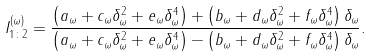Convert formula to latex. <formula><loc_0><loc_0><loc_500><loc_500>I _ { 1 \colon 2 } ^ { ( \omega ) } = \frac { \left ( a _ { \omega } + c _ { \omega } \delta _ { \omega } ^ { 2 } + e _ { \omega } \delta _ { \omega } ^ { 4 } \right ) + \left ( b _ { \omega } + d _ { \omega } \delta _ { \omega } ^ { 2 } + f _ { \omega } \delta _ { \omega } ^ { 4 } \right ) \delta _ { \omega } } { \left ( a _ { \omega } + c _ { \omega } \delta _ { \omega } ^ { 2 } + e _ { \omega } \delta _ { \omega } ^ { 4 } \right ) - \left ( b _ { \omega } + d _ { \omega } \delta _ { \omega } ^ { 2 } + f _ { \omega } \delta _ { \omega } ^ { 4 } \right ) \delta _ { \omega } } .</formula> 